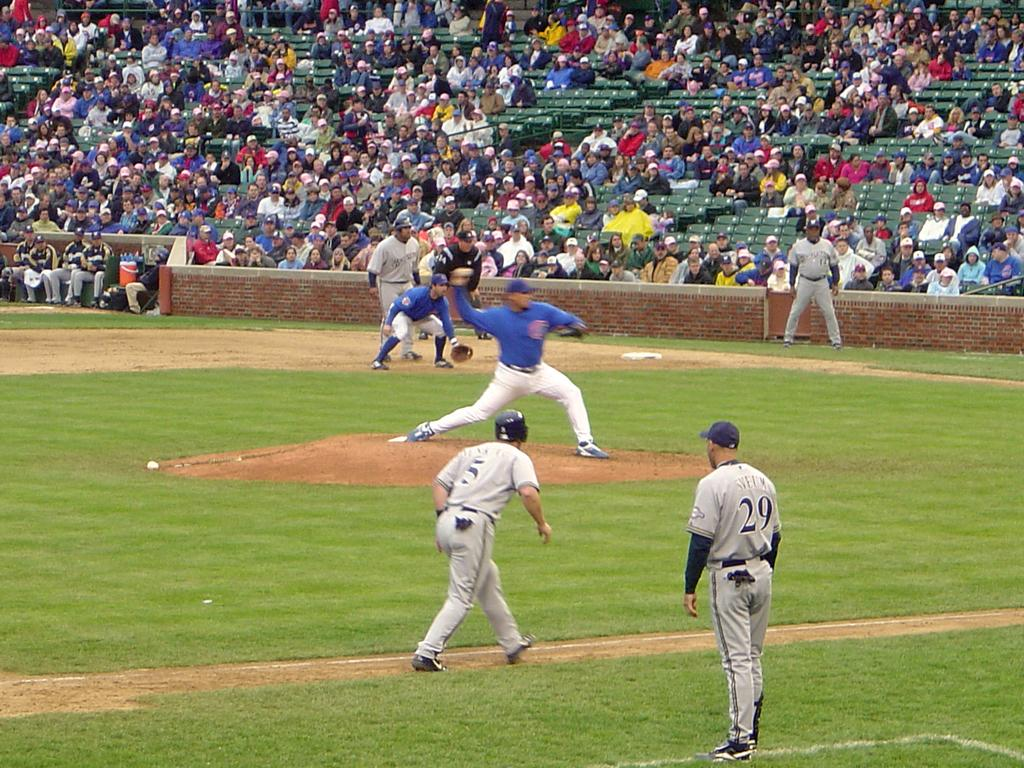<image>
Offer a succinct explanation of the picture presented. a baseball player throwing a ball and a coach with the number 29 on 